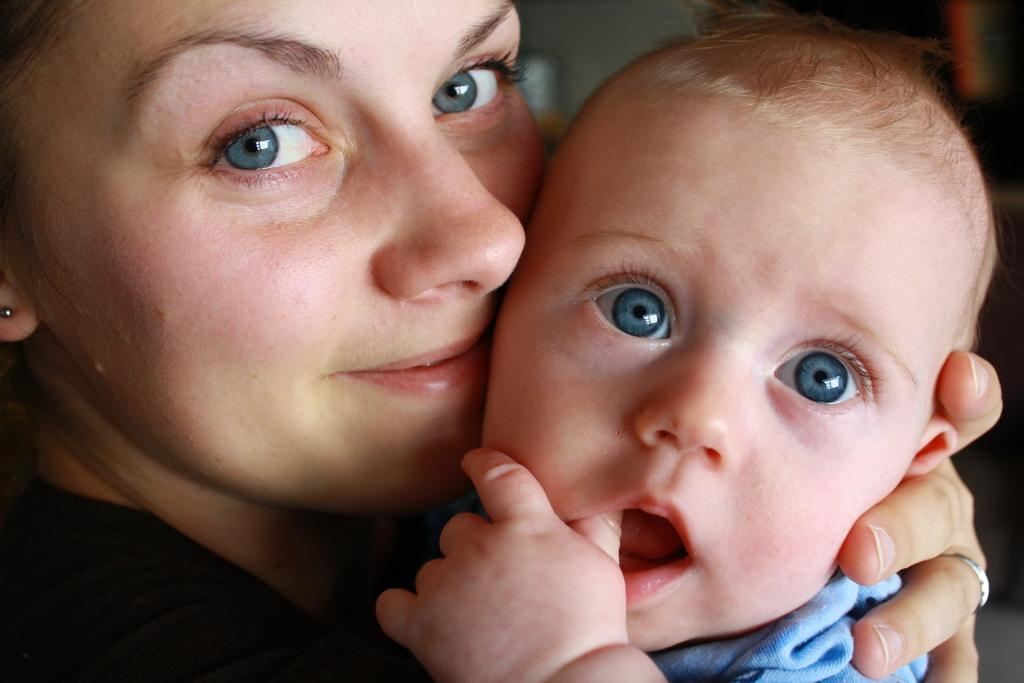Who is the main subject in the image? There is a lady in the image. What is the lady doing in the image? The lady is holding a baby. What type of cloud can be seen in the image? There is no cloud present in the image; it only features a lady holding a baby. What kind of thread is being used by the lady to hold the baby? The lady is not using any thread to hold the baby; she is simply holding the baby with her arms. 